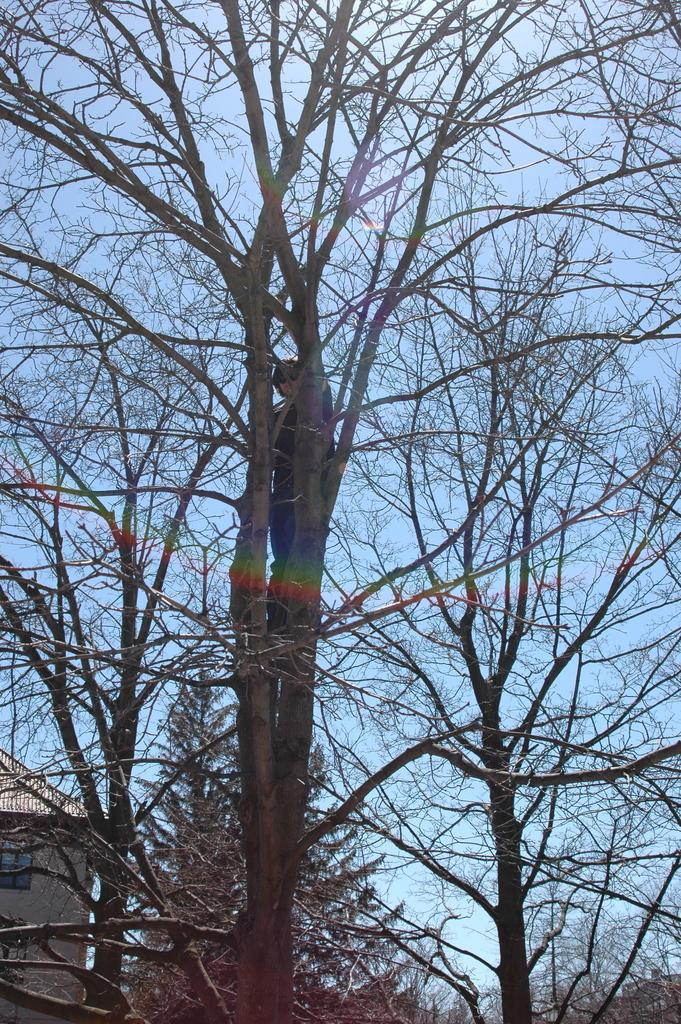What type of vegetation can be seen in the image? There are trees in the image. Can you describe the person's position in relation to the trees? A person is visible on top of the trees. What structure is located in the bottom left corner of the image? There is a house in the bottom left corner of the image. What is visible behind the trees in the image? The sky is visible behind the trees. What shape is the scent of the trees in the image? There is no scent of the trees mentioned in the image, and therefore no shape can be associated with it. 